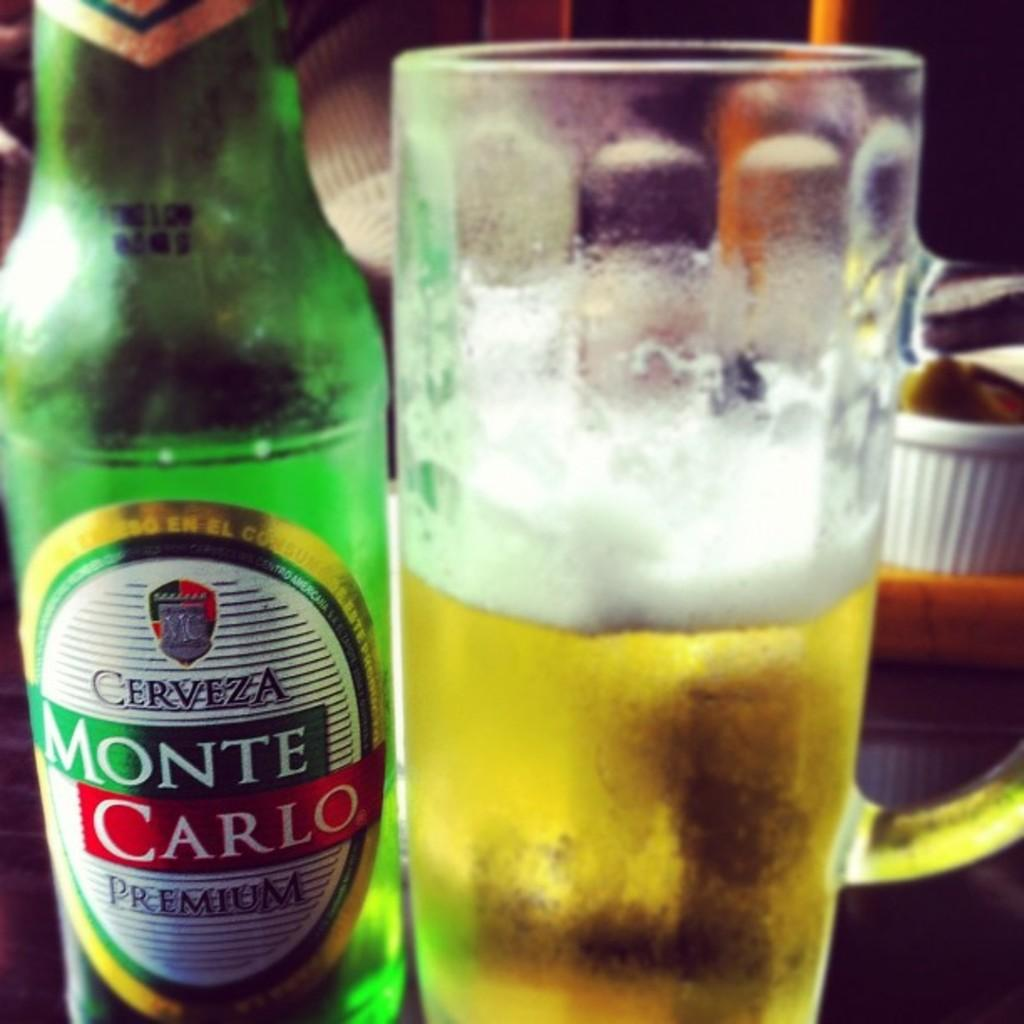Provide a one-sentence caption for the provided image. A bottle of Monte Carlo beer is to the left of a half empty mug of beer. 